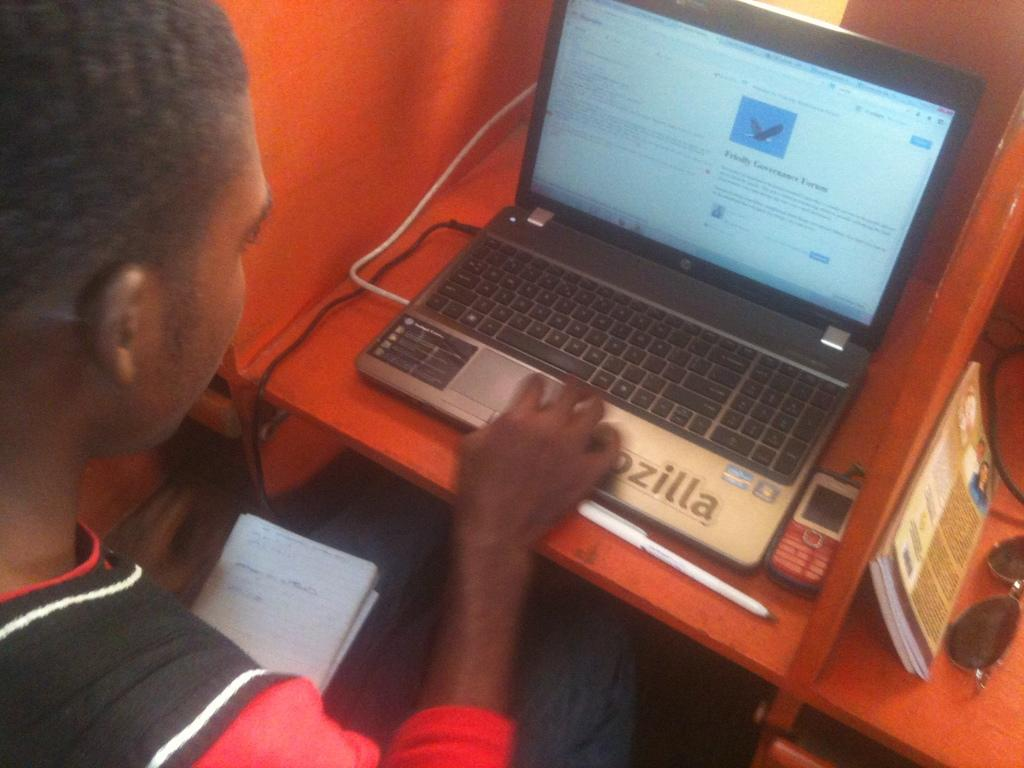<image>
Share a concise interpretation of the image provided. A man reads about Friendly Governance Forum on a computer. 